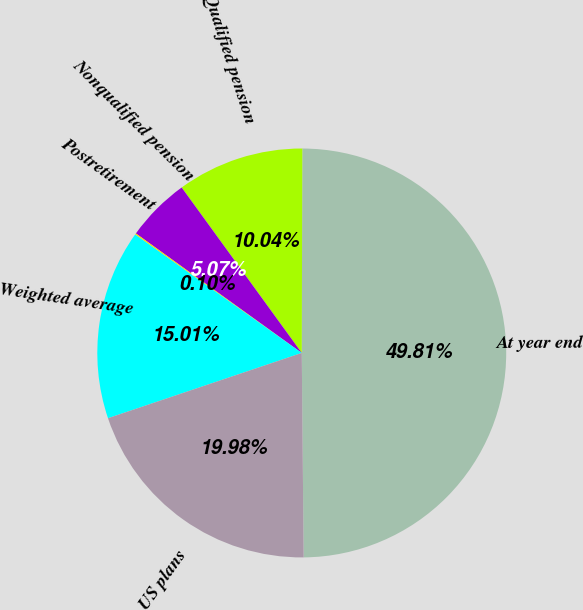Convert chart. <chart><loc_0><loc_0><loc_500><loc_500><pie_chart><fcel>At year end<fcel>Qualified pension<fcel>Nonqualified pension<fcel>Postretirement<fcel>Weighted average<fcel>US plans<nl><fcel>49.81%<fcel>10.04%<fcel>5.07%<fcel>0.1%<fcel>15.01%<fcel>19.98%<nl></chart> 